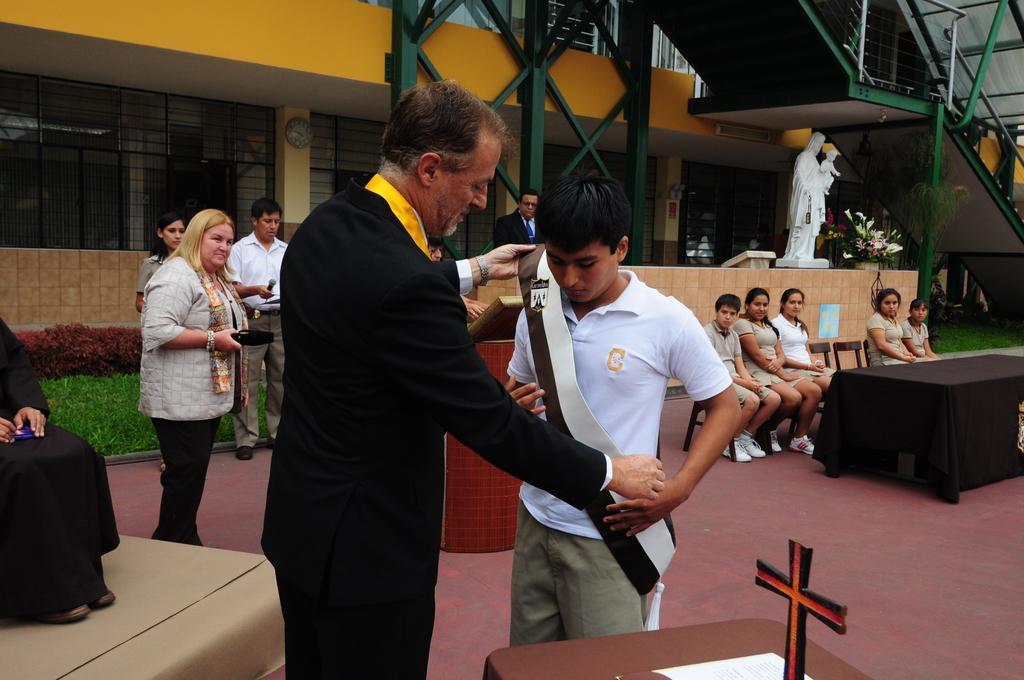Could you give a brief overview of what you see in this image? In this image, we can see a person wearing a sash to another person. In the background, there are people and some are sitting on the chairs and some are holding objects in their hands and we can see a building and there are railings, grilles, a clock on the wall and we can see a statue and some flower pots and there is a cloth on the table and we can see stands and a cross and a paper and bushes. At the bottom, there is a floor. 